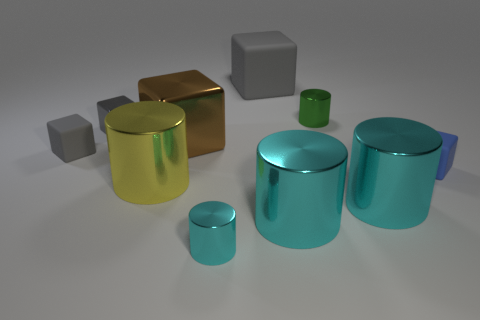There is a brown object to the right of the yellow metal thing; what is its shape? The shape of the brown object to the right of the yellow metal thing appears to be a cube with a slightly reflective surface, hinting at its three-dimensional form and bringing attention to its geometric characteristics. 